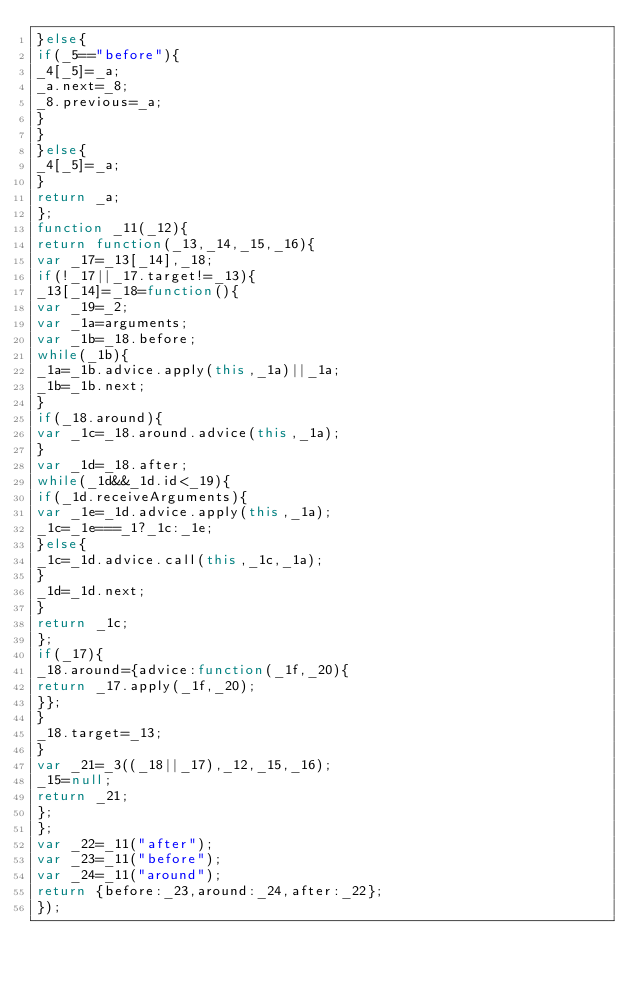<code> <loc_0><loc_0><loc_500><loc_500><_JavaScript_>}else{
if(_5=="before"){
_4[_5]=_a;
_a.next=_8;
_8.previous=_a;
}
}
}else{
_4[_5]=_a;
}
return _a;
};
function _11(_12){
return function(_13,_14,_15,_16){
var _17=_13[_14],_18;
if(!_17||_17.target!=_13){
_13[_14]=_18=function(){
var _19=_2;
var _1a=arguments;
var _1b=_18.before;
while(_1b){
_1a=_1b.advice.apply(this,_1a)||_1a;
_1b=_1b.next;
}
if(_18.around){
var _1c=_18.around.advice(this,_1a);
}
var _1d=_18.after;
while(_1d&&_1d.id<_19){
if(_1d.receiveArguments){
var _1e=_1d.advice.apply(this,_1a);
_1c=_1e===_1?_1c:_1e;
}else{
_1c=_1d.advice.call(this,_1c,_1a);
}
_1d=_1d.next;
}
return _1c;
};
if(_17){
_18.around={advice:function(_1f,_20){
return _17.apply(_1f,_20);
}};
}
_18.target=_13;
}
var _21=_3((_18||_17),_12,_15,_16);
_15=null;
return _21;
};
};
var _22=_11("after");
var _23=_11("before");
var _24=_11("around");
return {before:_23,around:_24,after:_22};
});
</code> 